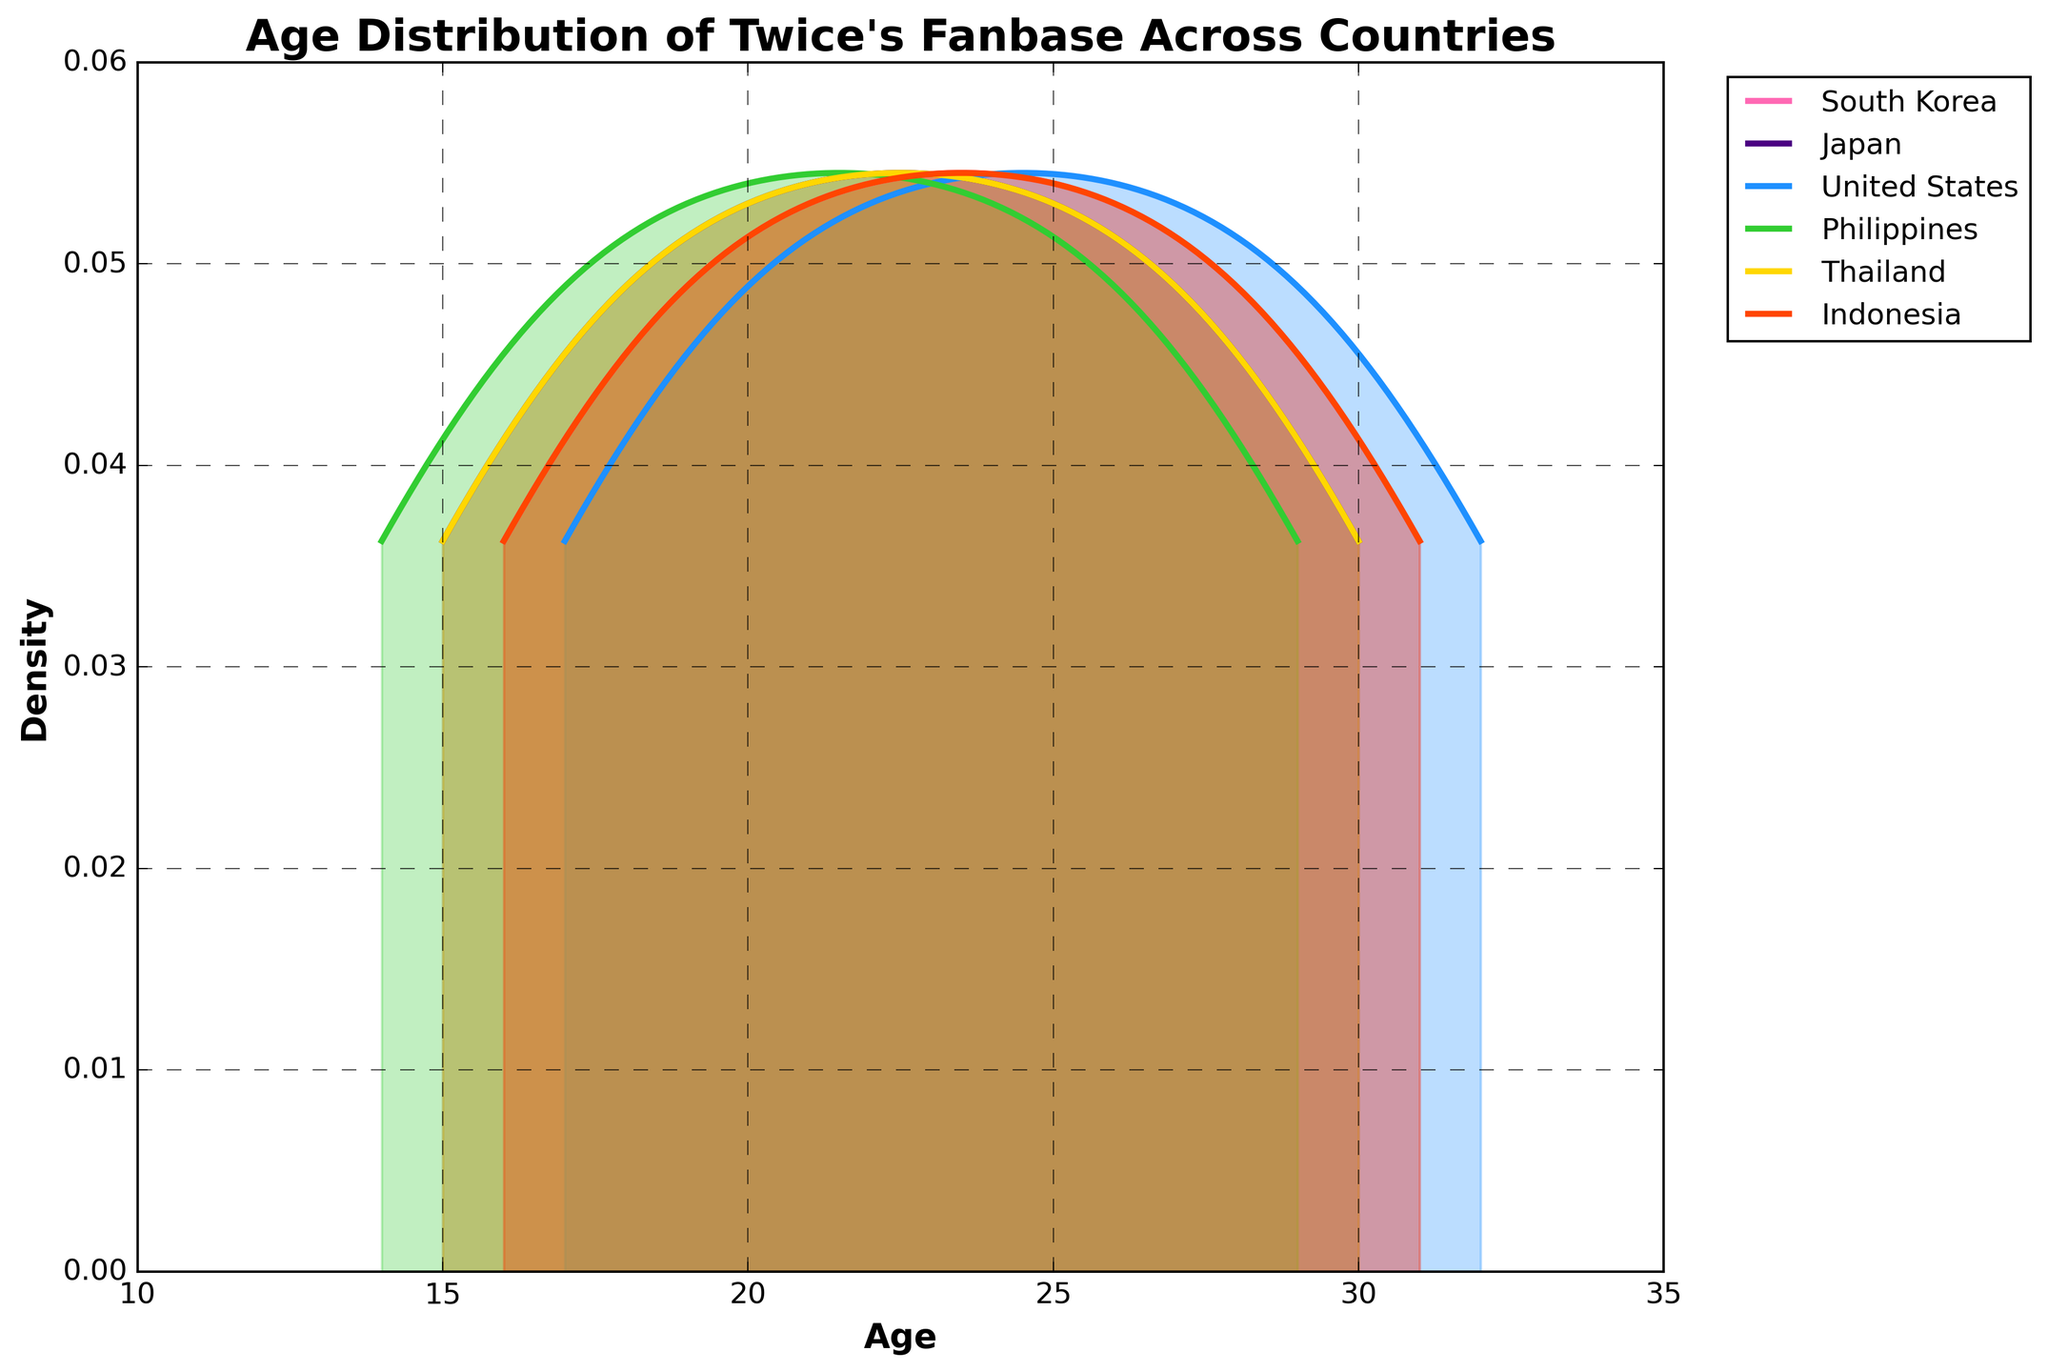What's the title of the plot? The title of the plot can be found at the top of the figure in bold text.
Answer: Age Distribution of Twice's Fanbase Across Countries Which country has the densest peak in the age range of 23-26? To find the densest peak, look at the height of the density curves within the specified age range and determine which country's curve reaches the highest point.
Answer: United States What are the age ranges covered by Twice's fanbase in South Korea? Inspect the horizontal spread of the density curve for South Korea from where it starts to where it ends, indicating the age range.
Answer: 16-31 Which country has the youngest peak age among Twice's fanbase? Look for the peak of the density curve for each country and identify the lowest age at which the peak occurs.
Answer: Philippines Compare the density of fans aged 21 in Japan and Thailand. Which country has a higher density? Observe the height of the density curves for Japan and Thailand at age 21 and compare them to see which is higher.
Answer: Japan What is the age range with the highest density of fans in South Korea? Identify the section of the density curve for South Korea with the highest peak and note the corresponding age range.
Answer: 22-25 Is there a country with a relatively uniform distribution of fan ages? A uniform distribution would have a flatter density curve without sharp peaks. Examine each country's curve for this characteristic.
Answer: No (all curves have distinct peaks) How many countries are represented in the plot? Count the number of unique labels or density curves in the legend.
Answer: 6 Which country has the most extended age range for its fanbase? Find the country whose density curve covers the widest horizontal span from start to end.
Answer: Indonesia Between which ages does the Philippines' fanbase density curve start and end? Identify the points on the horizontal axis where the Philippines' density curve begins and finishes.
Answer: 14-29 